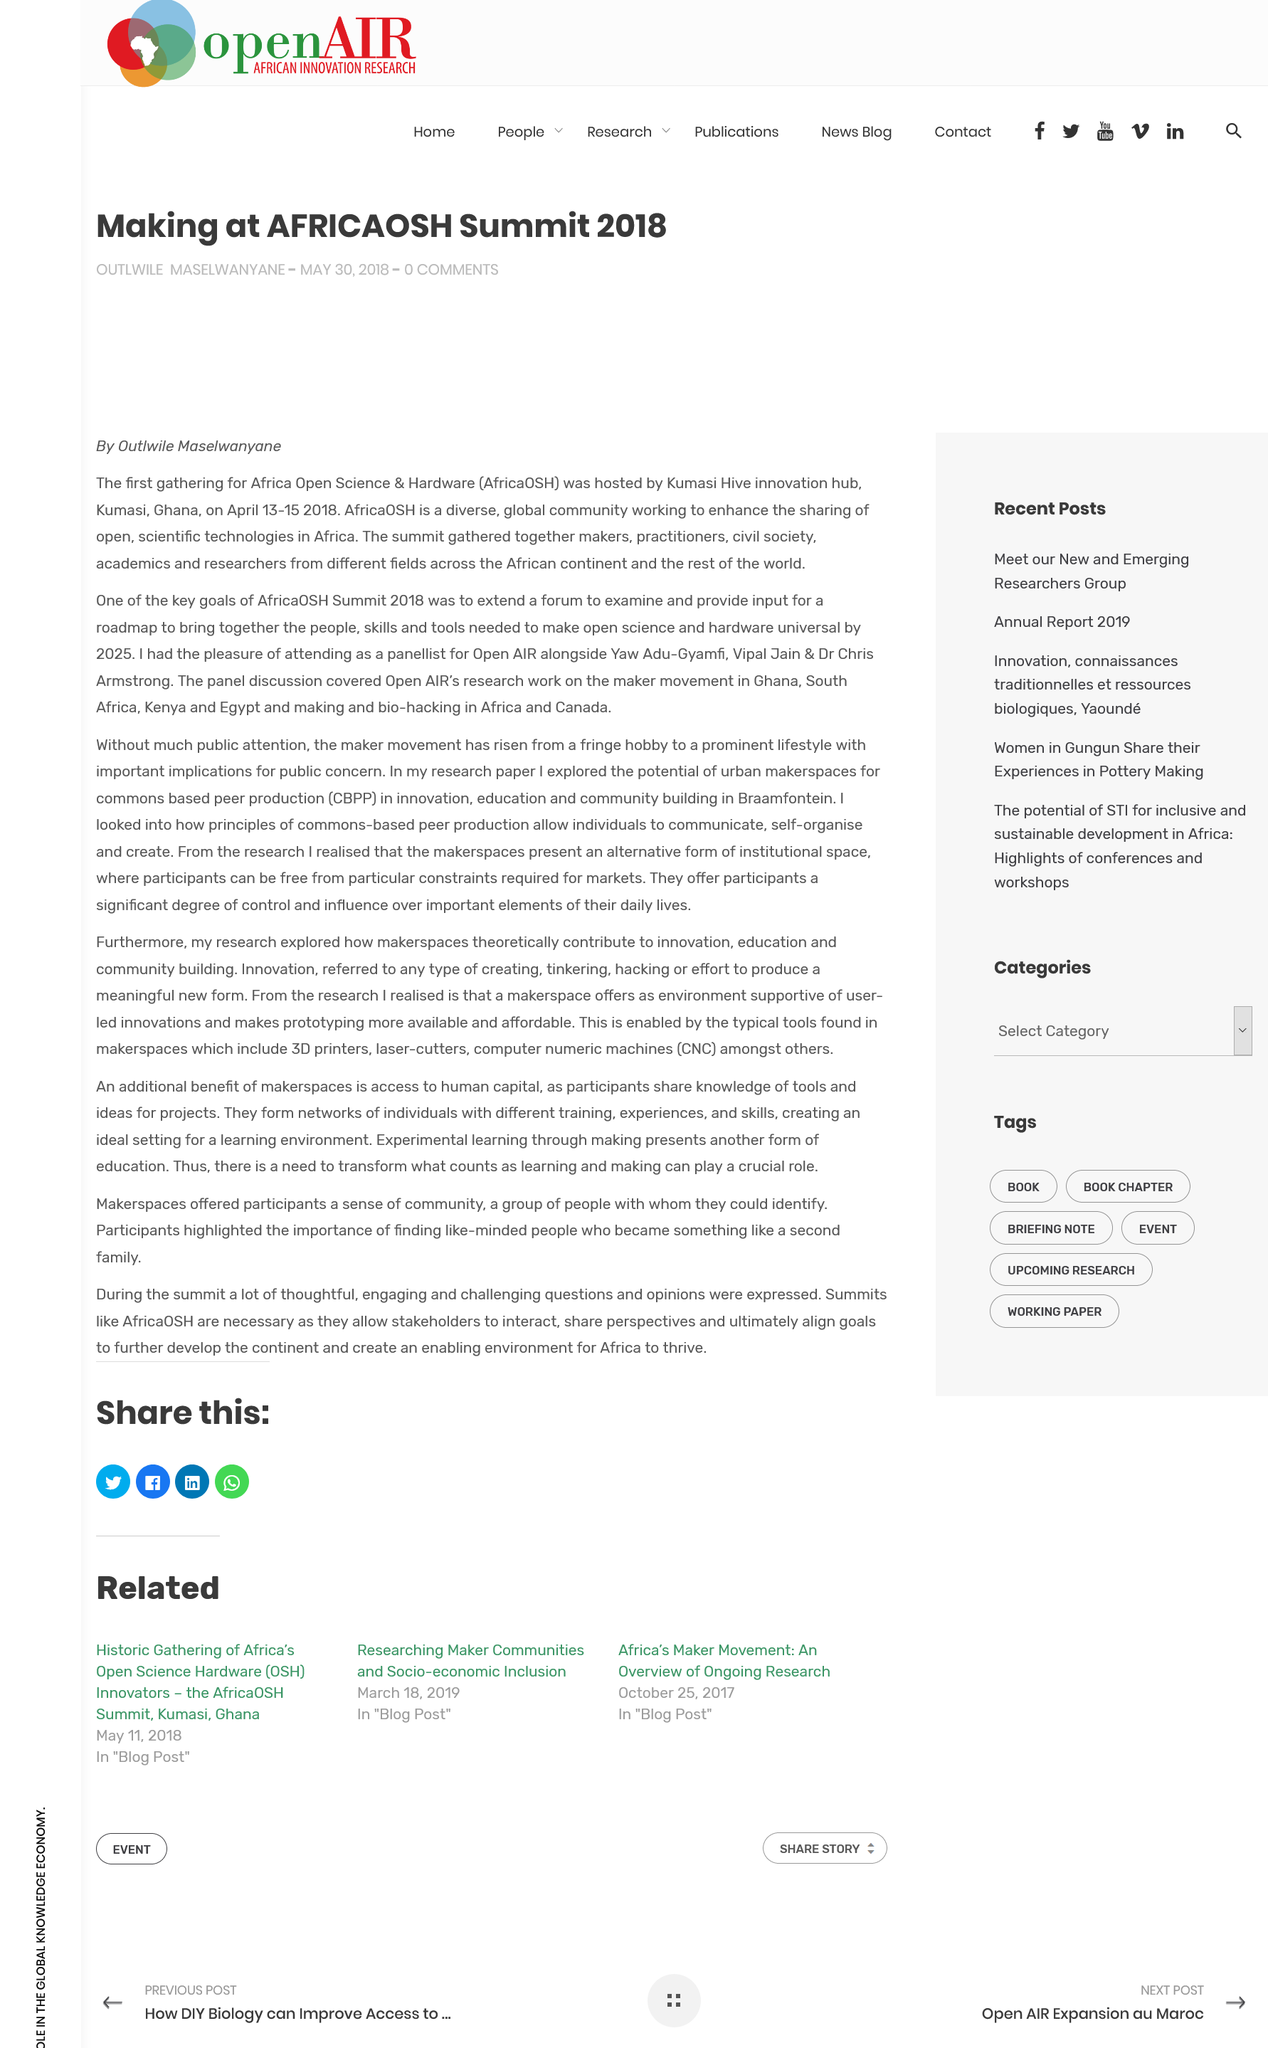List a handful of essential elements in this visual. The AfricaOSH Community group serves to promote the sharing of open and scientific technologies in Africa. The AfricaOSH summit aims to create a roadmap for universal open science and hardware by 2025 by examining and gathering input from experts in the field. The panel discussed the various aspects of Open AIR's work, specifically focusing on the maker movement, making, and bio-hacking. 